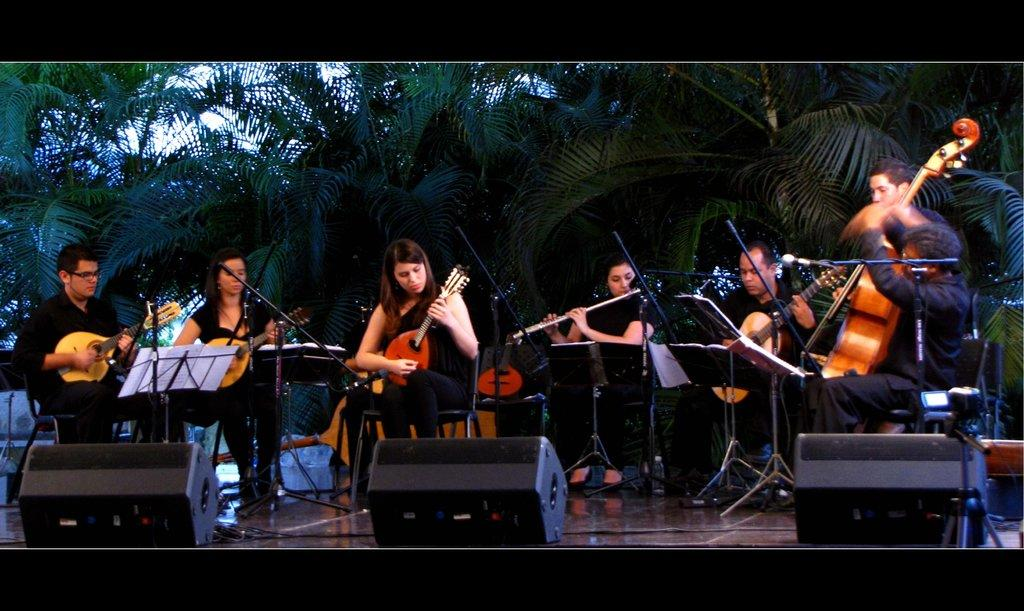What are the persons in the image doing? They are playing guitar. What are they sitting on while playing guitar? They are sitting on chairs. What can be seen beneath their feet in the image? The floor is visible in the image. What is visible in the background of the image? There are trees in the background of the image. What level of difficulty are they talking about while playing the guitar? There is no indication in the image that they are talking or discussing any level of difficulty while playing the guitar. 